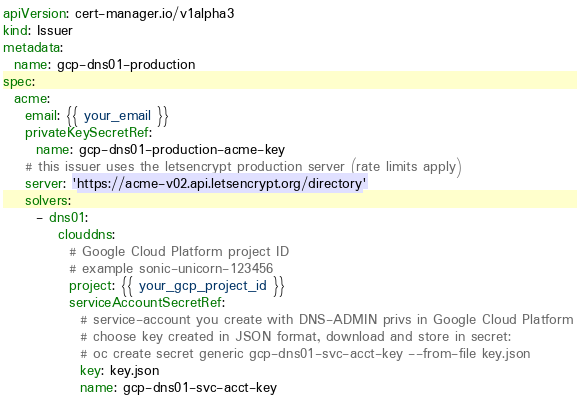<code> <loc_0><loc_0><loc_500><loc_500><_YAML_>apiVersion: cert-manager.io/v1alpha3
kind: Issuer
metadata:
  name: gcp-dns01-production
spec:
  acme:
    email: {{ your_email }}
    privateKeySecretRef:
      name: gcp-dns01-production-acme-key
    # this issuer uses the letsencrypt production server (rate limits apply)
    server: 'https://acme-v02.api.letsencrypt.org/directory'
    solvers:
      - dns01:
          clouddns:
            # Google Cloud Platform project ID
            # example sonic-unicorn-123456
            project: {{ your_gcp_project_id }}
            serviceAccountSecretRef:
              # service-account you create with DNS-ADMIN privs in Google Cloud Platform
              # choose key created in JSON format, download and store in secret:
              # oc create secret generic gcp-dns01-svc-acct-key --from-file key.json
              key: key.json
              name: gcp-dns01-svc-acct-key
</code> 